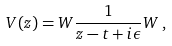<formula> <loc_0><loc_0><loc_500><loc_500>V ( z ) = W \frac { 1 } { z - t + i \epsilon } W \, ,</formula> 